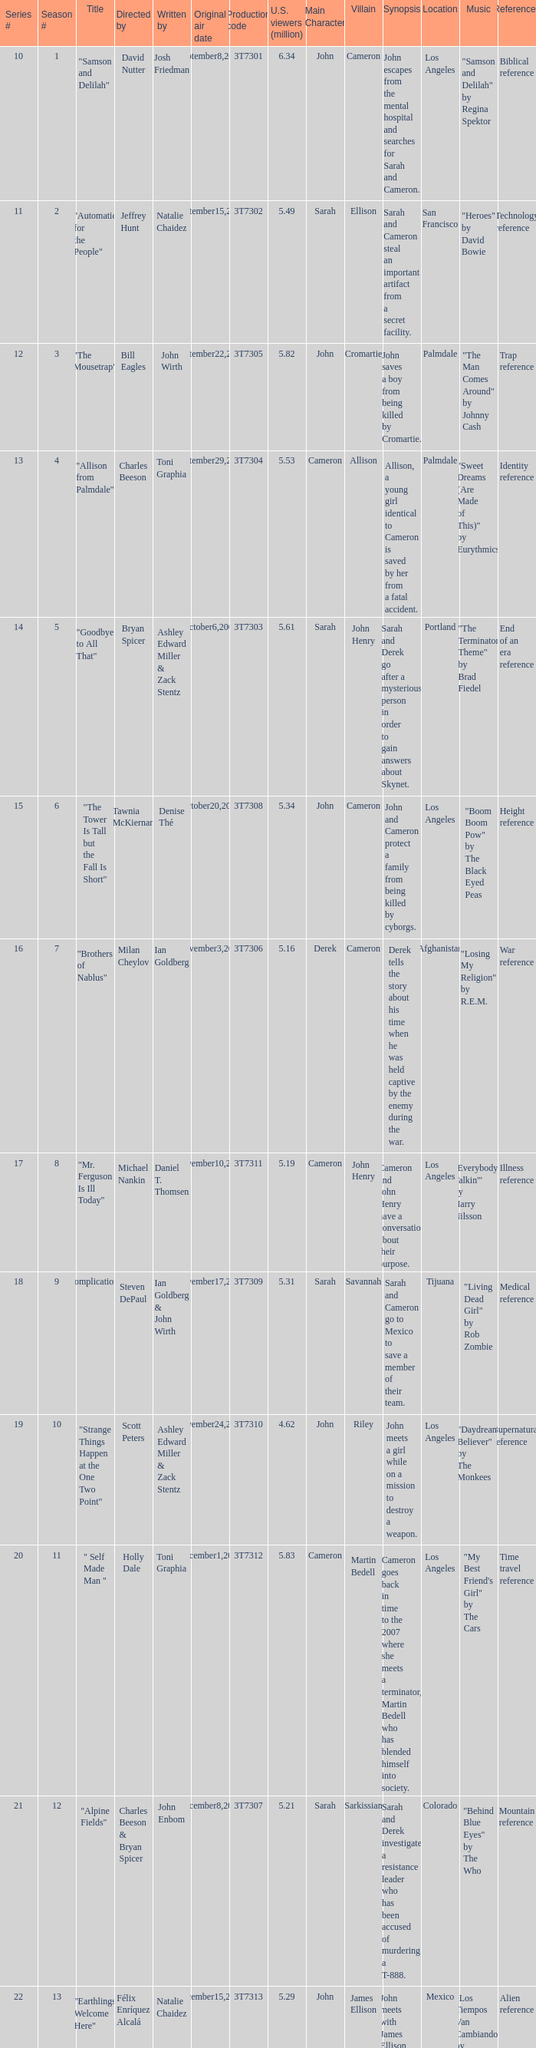How many viewers did the episode directed by David Nutter draw in? 6.34. 